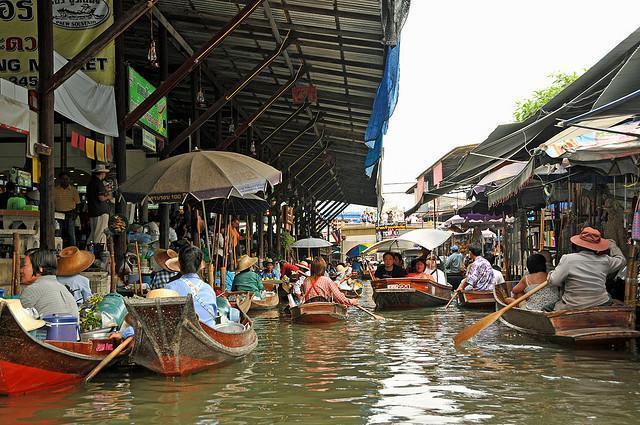How many people can you see?
Give a very brief answer. 4. How many boats are in the picture?
Give a very brief answer. 4. 